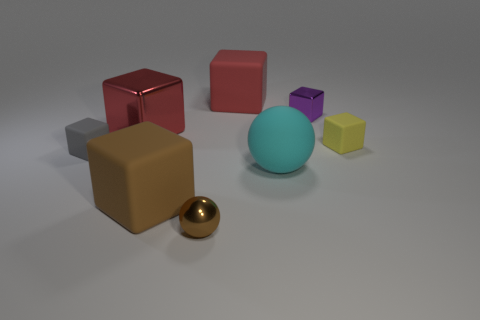There is a large rubber block to the right of the large brown block; is it the same color as the metal cube on the left side of the purple metallic block?
Your answer should be compact. Yes. There is a gray rubber cube that is behind the big cyan matte ball; is its size the same as the red thing in front of the purple cube?
Give a very brief answer. No. There is a red thing left of the big red object that is on the right side of the large red metallic block to the right of the small gray cube; what is it made of?
Your answer should be very brief. Metal. Does the tiny gray matte object have the same shape as the yellow thing?
Keep it short and to the point. Yes. There is a purple object that is the same shape as the gray rubber object; what material is it?
Provide a short and direct response. Metal. What number of other metallic cubes are the same color as the tiny metallic cube?
Ensure brevity in your answer.  0. There is another cube that is the same material as the purple block; what size is it?
Offer a very short reply. Large. How many green objects are large objects or metal spheres?
Make the answer very short. 0. What number of large shiny things are on the right side of the tiny matte object to the right of the purple thing?
Ensure brevity in your answer.  0. Is the number of brown objects that are on the left side of the small brown metal object greater than the number of big rubber spheres behind the purple metal thing?
Offer a terse response. Yes. 